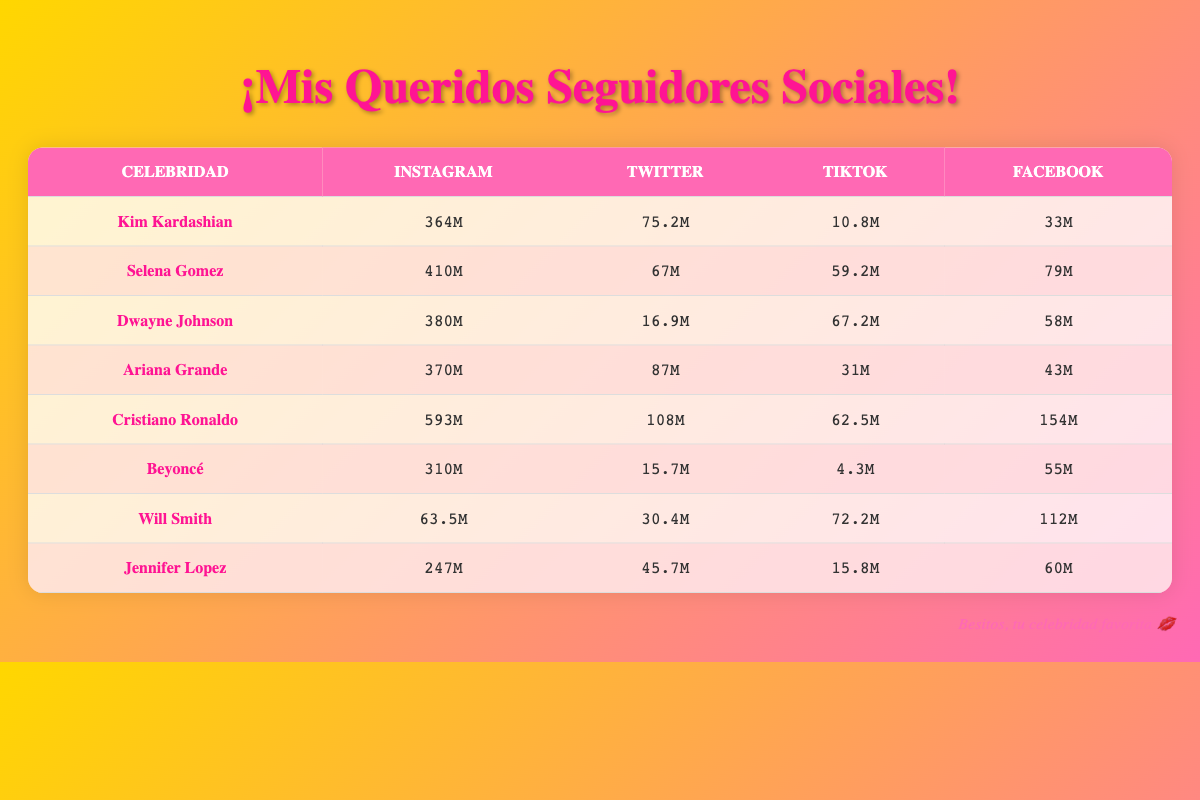¿Cuántos seguidores en Instagram tiene Cristiano Ronaldo? La tabla muestra que Cristiano Ronaldo tiene 593 millones de seguidores en Instagram.
Answer: 593M ¿Quién tiene más seguidores en Twitter, Kim Kardashian o Dwayne Johnson? Kim Kardashian tiene 75.2 millones de seguidores en Twitter, mientras que Dwayne Johnson tiene 16.9 millones. Por lo tanto, Kim Kardashian tiene más seguidores en Twitter.
Answer: Kim Kardashian ¿Cuántos seguidores tiene Ariana Grande en TikTok? Según la tabla, Ariana Grande tiene 31 millones de seguidores en TikTok.
Answer: 31M Si sumas los seguidores en Facebook de Selena Gomez y Jennifer Lopez, ¿cuántos seguidores tendrías en total? Selena Gomez tiene 79 millones y Jennifer Lopez tiene 60 millones. Al sumar 79 + 60, obtenemos 139 millones.
Answer: 139M ¿Es cierto que Beyoncé tiene más seguidores en Instagram que en Facebook? Según la información en la tabla, Beyoncé tiene 310 millones de seguidores en Instagram y 55 millones en Facebook. Por lo tanto, es cierto que tiene más en Instagram.
Answer: Sí ¿Cuál es la diferencia entre los seguidores en TikTok de Dwayne Johnson y Will Smith? Dwayne Johnson tiene 67.2 millones de seguidores en TikTok y Will Smith tiene 72.2 millones. La diferencia es 72.2 - 67.2 = 5 millones.
Answer: 5M ¿Cuántos seguidores en total tienen los tres primeros en la lista (Kim Kardashian, Selena Gomez y Dwayne Johnson) en Instagram? Sumando los seguidores en Instagram, tenemos 364M (Kim) + 410M (Selena) + 380M (Dwayne) = 1154 millones.
Answer: 1154M ¿Selena Gomez tiene más seguidores en Facebook que Ariana Grande? Selena Gomez tiene 79 millones en Facebook y Ariana Grande tiene 43 millones. Por lo tanto, Selena Gomez tiene más seguidores en Facebook.
Answer: Sí 